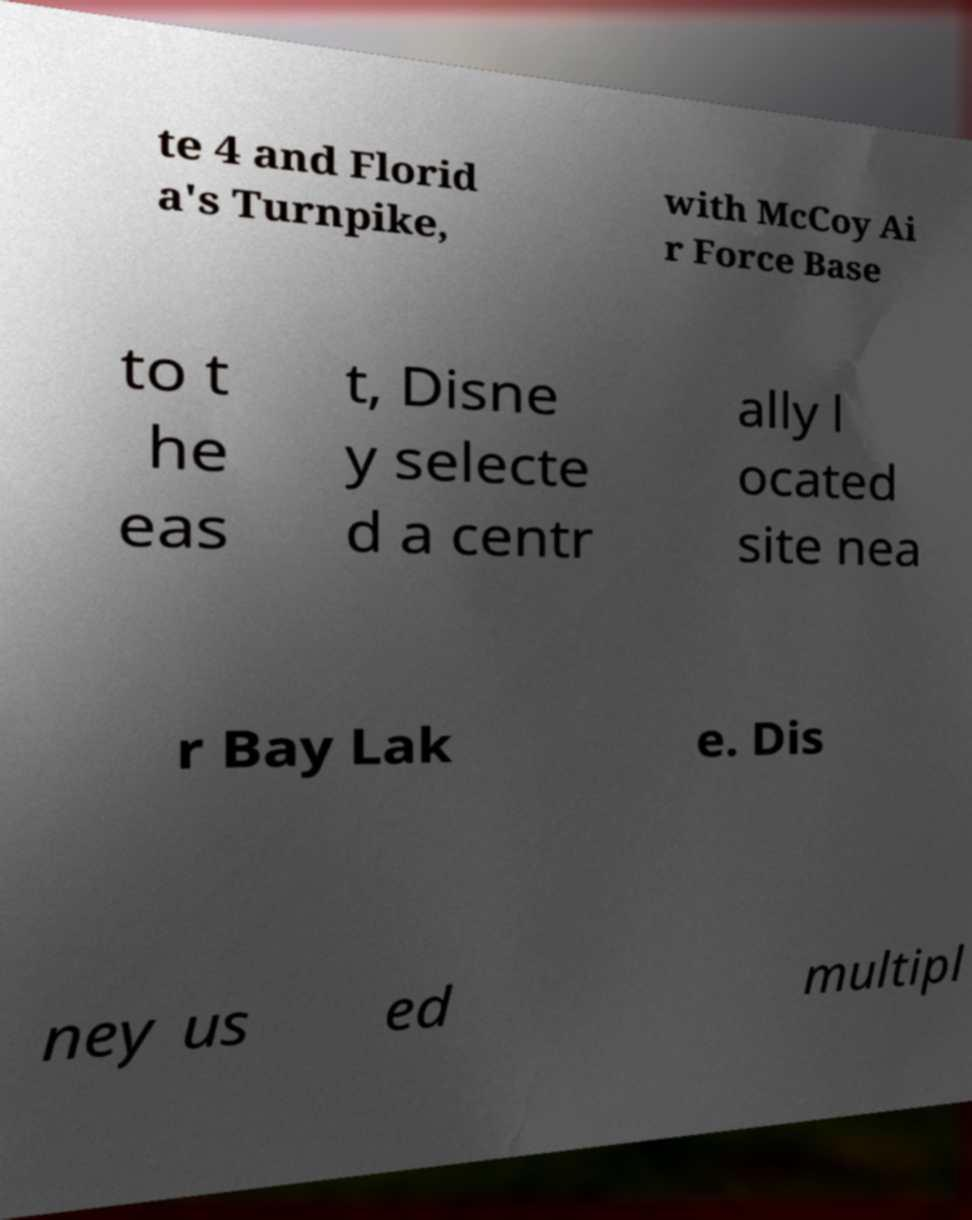Can you accurately transcribe the text from the provided image for me? te 4 and Florid a's Turnpike, with McCoy Ai r Force Base to t he eas t, Disne y selecte d a centr ally l ocated site nea r Bay Lak e. Dis ney us ed multipl 